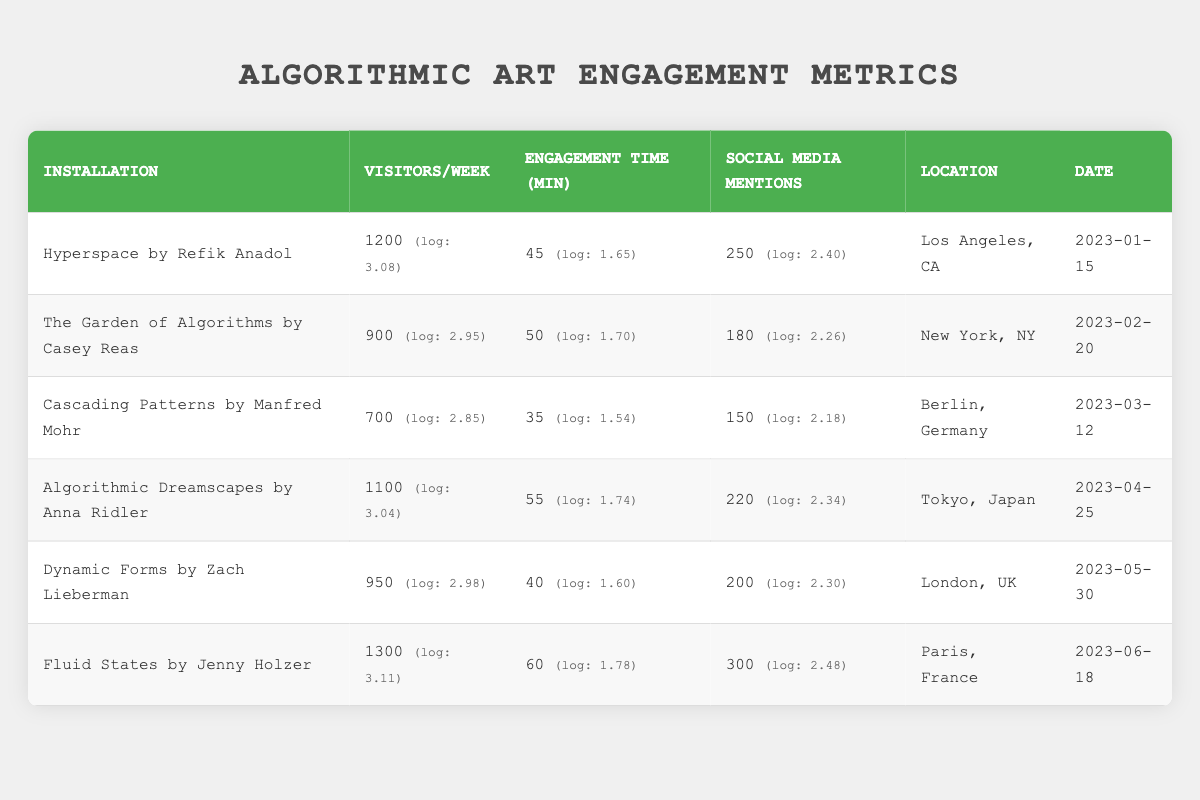What is the engagement time in minutes for "Fluid States by Jenny Holzer"? Looking at the table, I find the row for "Fluid States by Jenny Holzer" where the engagement time in minutes is listed as 60.
Answer: 60 Which installation had the highest number of visitors per week? The installations are listed in the table with their respective visitors per week. "Fluid States by Jenny Holzer" has the highest value at 1300 visitors per week.
Answer: Fluid States by Jenny Holzer What is the average engagement time (in minutes) across all installations? First, I sum the engagement times: 45 + 50 + 35 + 55 + 40 + 60 = 285. There are 6 installations, so I divide by 6 to get the average: 285/6 = 47.5.
Answer: 47.5 Did "The Garden of Algorithms by Casey Reas" have more social media mentions than "Dynamic Forms by Zach Lieberman"? "The Garden of Algorithms by Casey Reas" has 180 social media mentions and "Dynamic Forms by Zach Lieberman" has 200. Since 180 is less than 200, the answer is no.
Answer: No What is the difference in social media mentions between "Hyperspace by Refik Anadol" and "Cascading Patterns by Manfred Mohr"? "Hyperspace by Refik Anadol" has 250 social media mentions and "Cascading Patterns by Manfred Mohr" has 150. The difference is 250 - 150 = 100.
Answer: 100 Which location had the second highest number of visitors per week? Sorting the visitors per week values, we have 1300, 1200, 1100, 950, 900, and 700. The second highest is 1200, which corresponds to "Hyperspace by Refik Anadol" in Los Angeles, CA.
Answer: Los Angeles, CA Is the average number of visitors per week across all installations greater than 1000? Summing the visitors: 1200 + 900 + 700 + 1100 + 950 + 1300 = 5150. Dividing by 6 gives an average of 5150/6 = 858.33, which is less than 1000. Therefore, the answer is no.
Answer: No Which installation had the longest engagement time and how much was it? Looking through the engagement times, "Fluid States by Jenny Holzer" has the highest engagement time of 60 minutes.
Answer: Fluid States by Jenny Holzer, 60 minutes What is the median number of visitors per week across these installations? The sorted values of visitors are 700, 900, 950, 1100, 1200, 1300. With 6 values, the median is the average of the 3rd and 4th values: (950 + 1100) / 2 = 1025.
Answer: 1025 